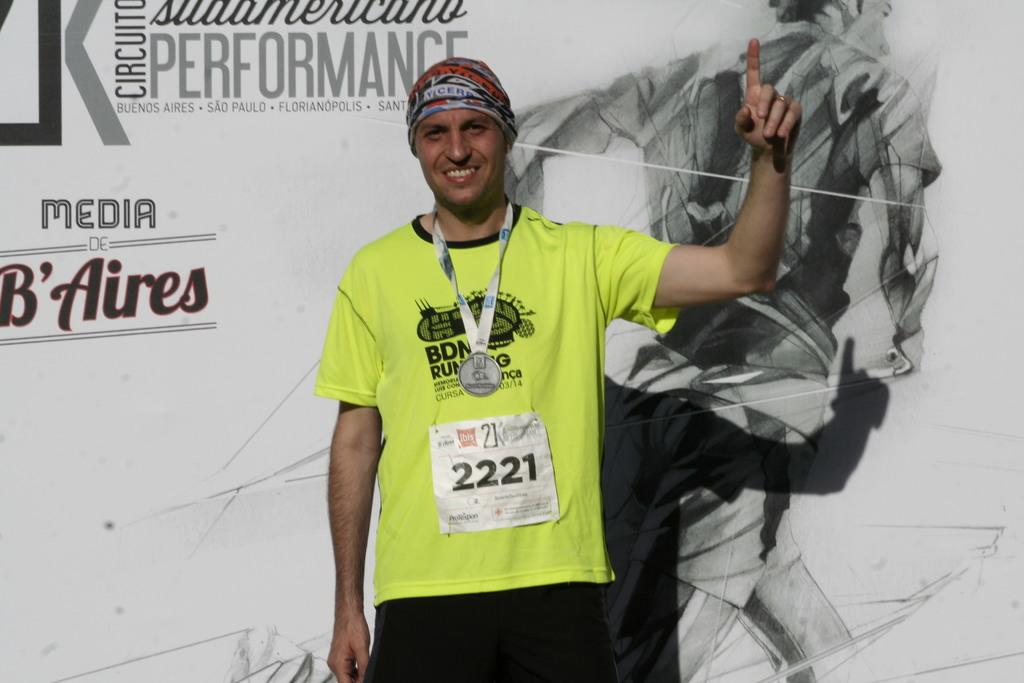Who or what is in the image? There is a person in the image. What is the person wearing? The person is wearing a light green dress. What is the person's posture in the image? The person is standing. What can be seen behind the person? There is a banner behind the person. Can you hear the person crying in the image? There is no indication of crying or any sound in the image, as it is a still photograph. 